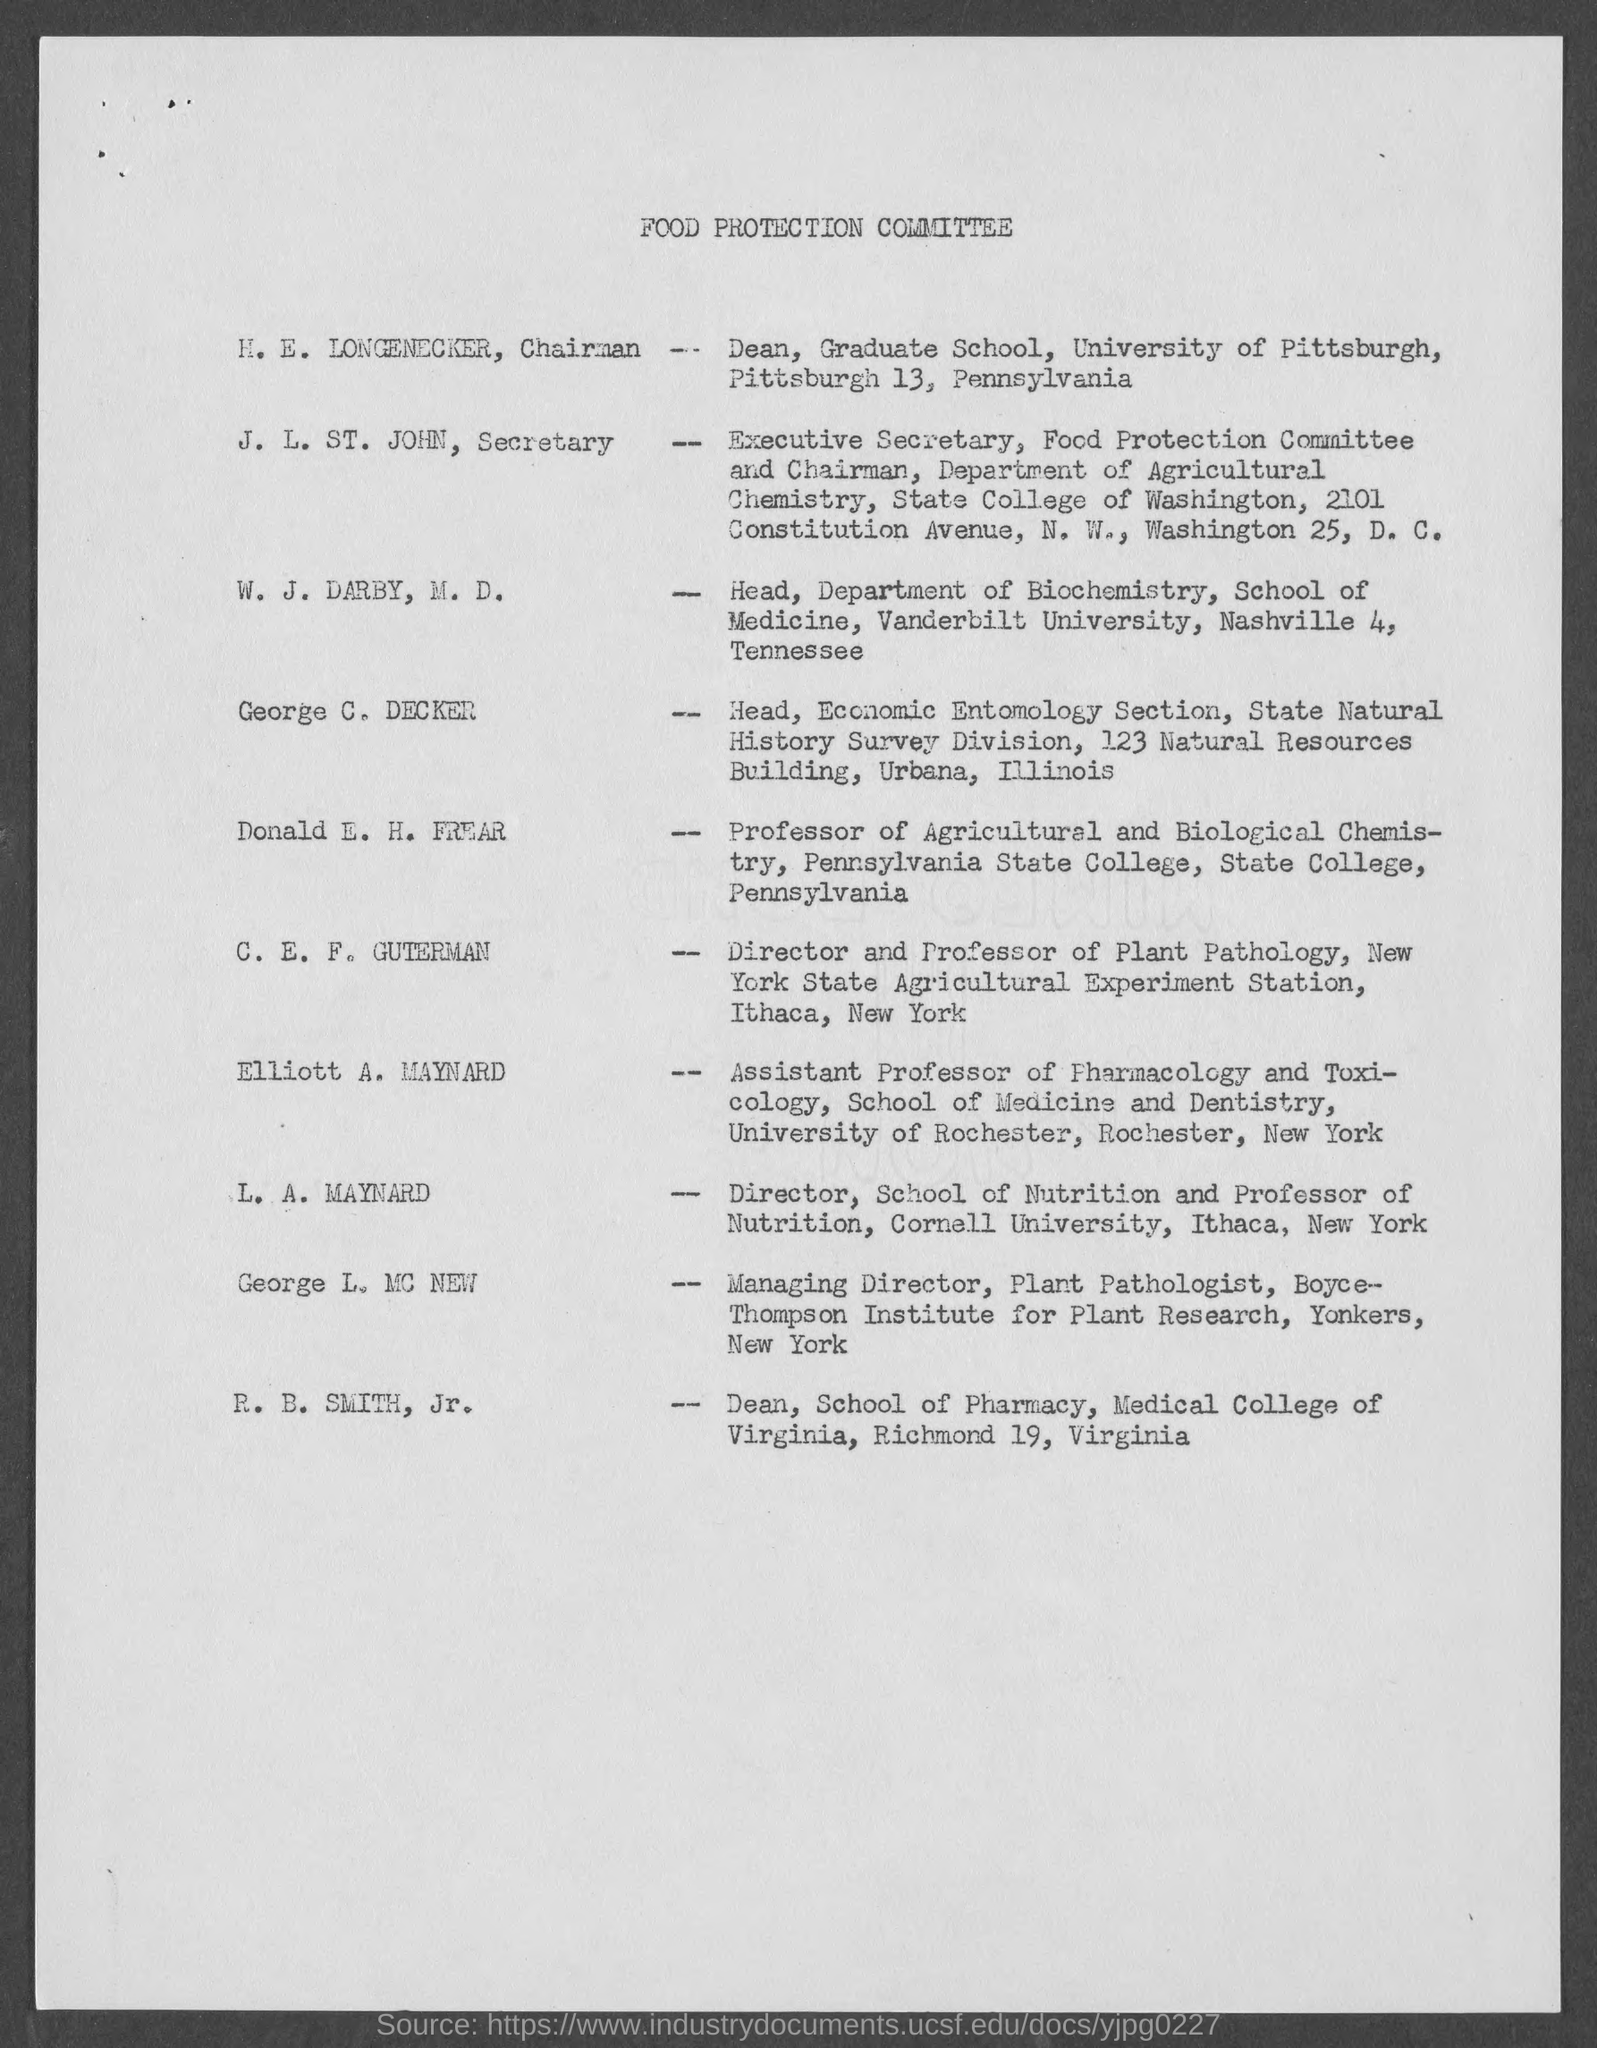What is the name of the committee?
Your answer should be compact. Food Protection Committee. Who is the secretary of food protection committee ?
Ensure brevity in your answer.  J. L. ST. John. Who is dean of school of pharmacy, medical college of virginia?
Ensure brevity in your answer.  R. b. smith, jr. Who is the managing director, plant pathologist, boyce- thompson institute for plant research?
Your response must be concise. George L. MC NEW. Who is the head, economic entomology section, state natural history survey division?
Keep it short and to the point. George c. decker. Who is the director and professor of plant pathology, new york state agriculture experiment station?
Provide a short and direct response. C. e. f. guterman. Who is the director, school of nutrition and professor of nutrition?
Keep it short and to the point. L. A. Maynard. Who is the professor of agricultural and biological chemistry, pennsylvania state college?
Your response must be concise. Donald e. h. frear. 